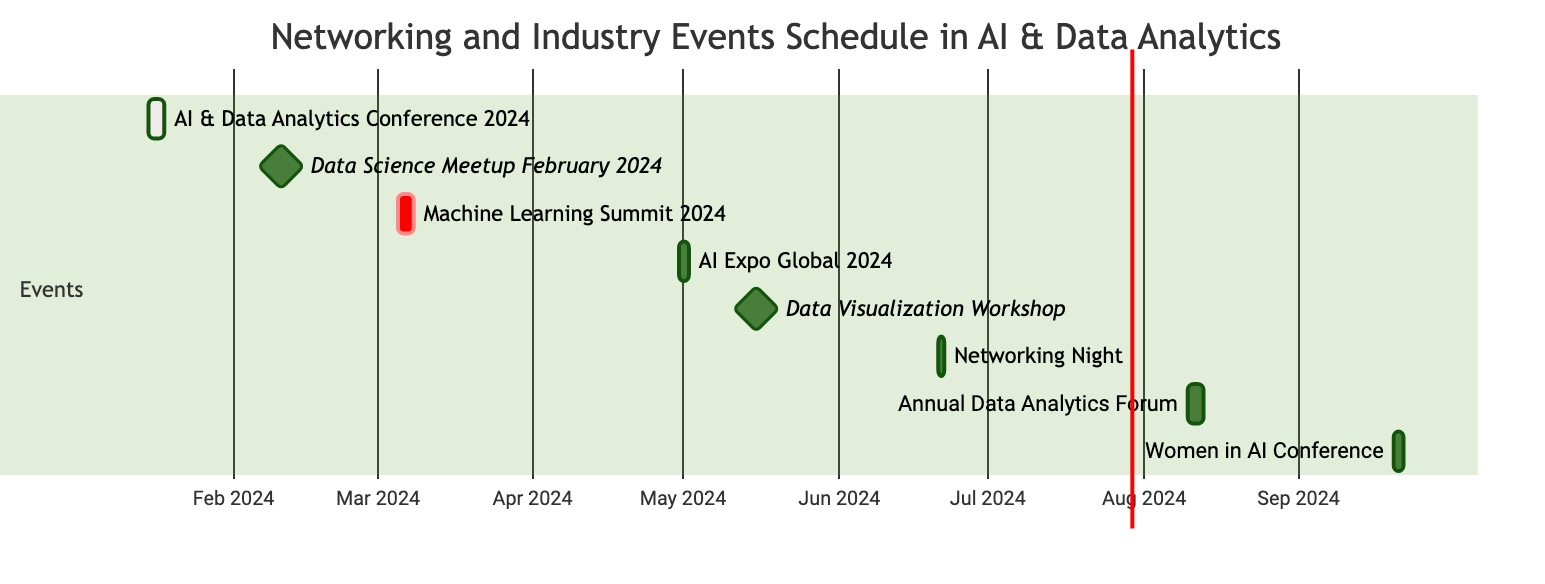What is the duration of the AI & Data Analytics Conference 2024? The event starts on January 15, 2024, and ends on January 17, 2024. To find the duration, subtract the start date from the end date: January 17 - January 15 = 2 days. Therefore, the duration is calculated as 3 days including the start date.
Answer: 3 days How many events take place in March 2024? Reviewing the diagram, we see that there is one event scheduled in March 2024, which is the Machine Learning Summit from March 5 to March 7. This is the only event within that month, so we only count it once.
Answer: 1 event Where is the Data Science Meetup February 2024 held? Looking at the event details, the Data Science Meetup February 2024 is indicated to be held in New York, NY, so we directly reference the location mentioned in the diagram.
Answer: New York, NY Which event begins immediately after the Data Visualization Workshop? The Data Visualization Workshop occurs on May 15, 2024. The next event listed is Networking Night: AI Professionals which occurs on June 21, 2024. By observing the timeline, there's this clear gap, indicating Networking Night is the immediate subsequent event.
Answer: Networking Night: AI Professionals What are the total number of events scheduled in 2024? Counting all the events listed in the diagram, we find a total of 8 events scheduled for 2024. Each event is represented as a unique entry in the diagram, and we confirm this by counting them one by one.
Answer: 8 events How long is the Annual Data Analytics Forum scheduled for? This forum is scheduled from August 10 to August 12, 2024. By subtracting the start date from the end date, we get August 12 - August 10 = 2 days. Hence, including the start day, the total is 3 days for this event.
Answer: 3 days Which location hosts the Women in AI Conference? The diagram specifies that the Women in AI Conference is taking place in Toronto, Canada. This is stated directly in the event details associated with the conference.
Answer: Toronto, Canada What is the first event of 2024? The first event listed in the schedule starts on January 15, 2024, which corresponds to the AI & Data Analytics Conference. By examining the timeline sequentially, we identify this event as the first.
Answer: AI & Data Analytics Conference 2024 